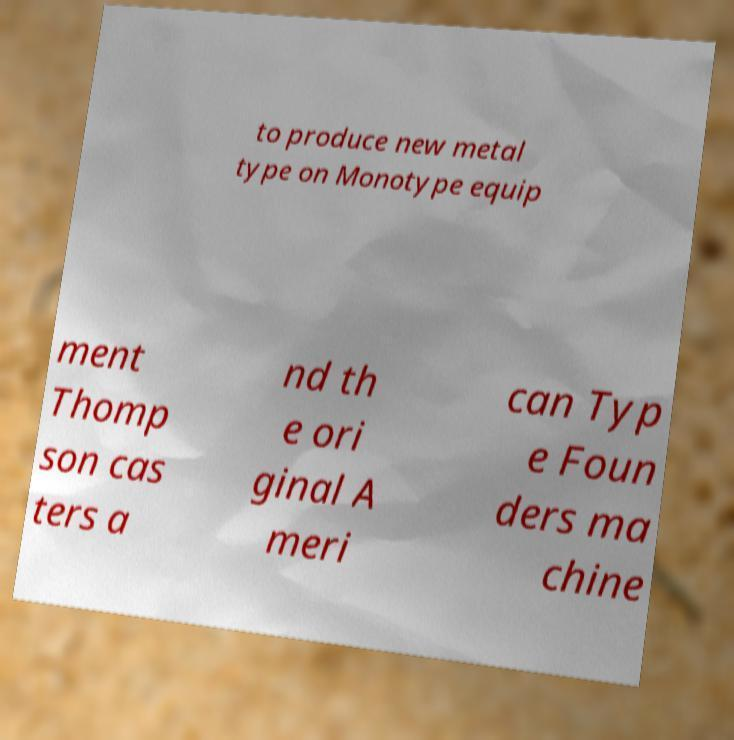I need the written content from this picture converted into text. Can you do that? to produce new metal type on Monotype equip ment Thomp son cas ters a nd th e ori ginal A meri can Typ e Foun ders ma chine 